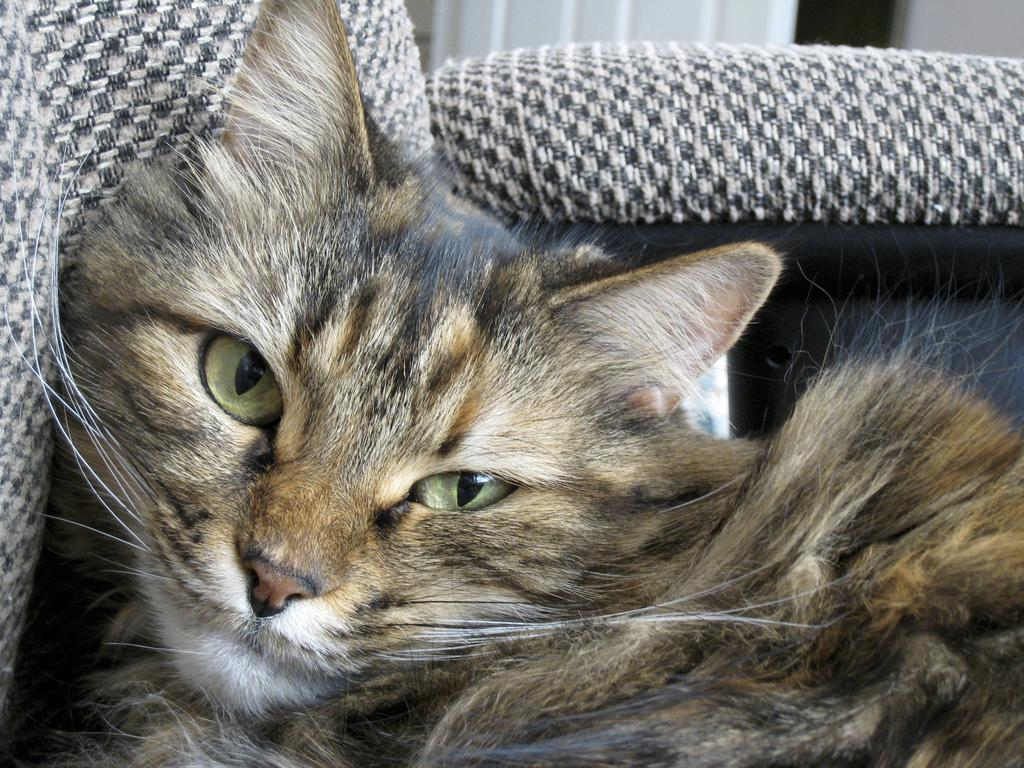What animal is in the front of the image? There is a cat in the front of the image. What type of furniture can be seen in the background of the image? There is a sofa in the background of the image. What is the color of the door in the background of the image? The door is white in color. Can you describe the door's location in relation to the sofa? The door is in the background of the image, and it is likely near the sofa. Is there any quicksand visible in the image? No, there is no quicksand present in the image. What type of club is the cat holding in the image? There is no club visible in the image; the cat is not holding any object. 